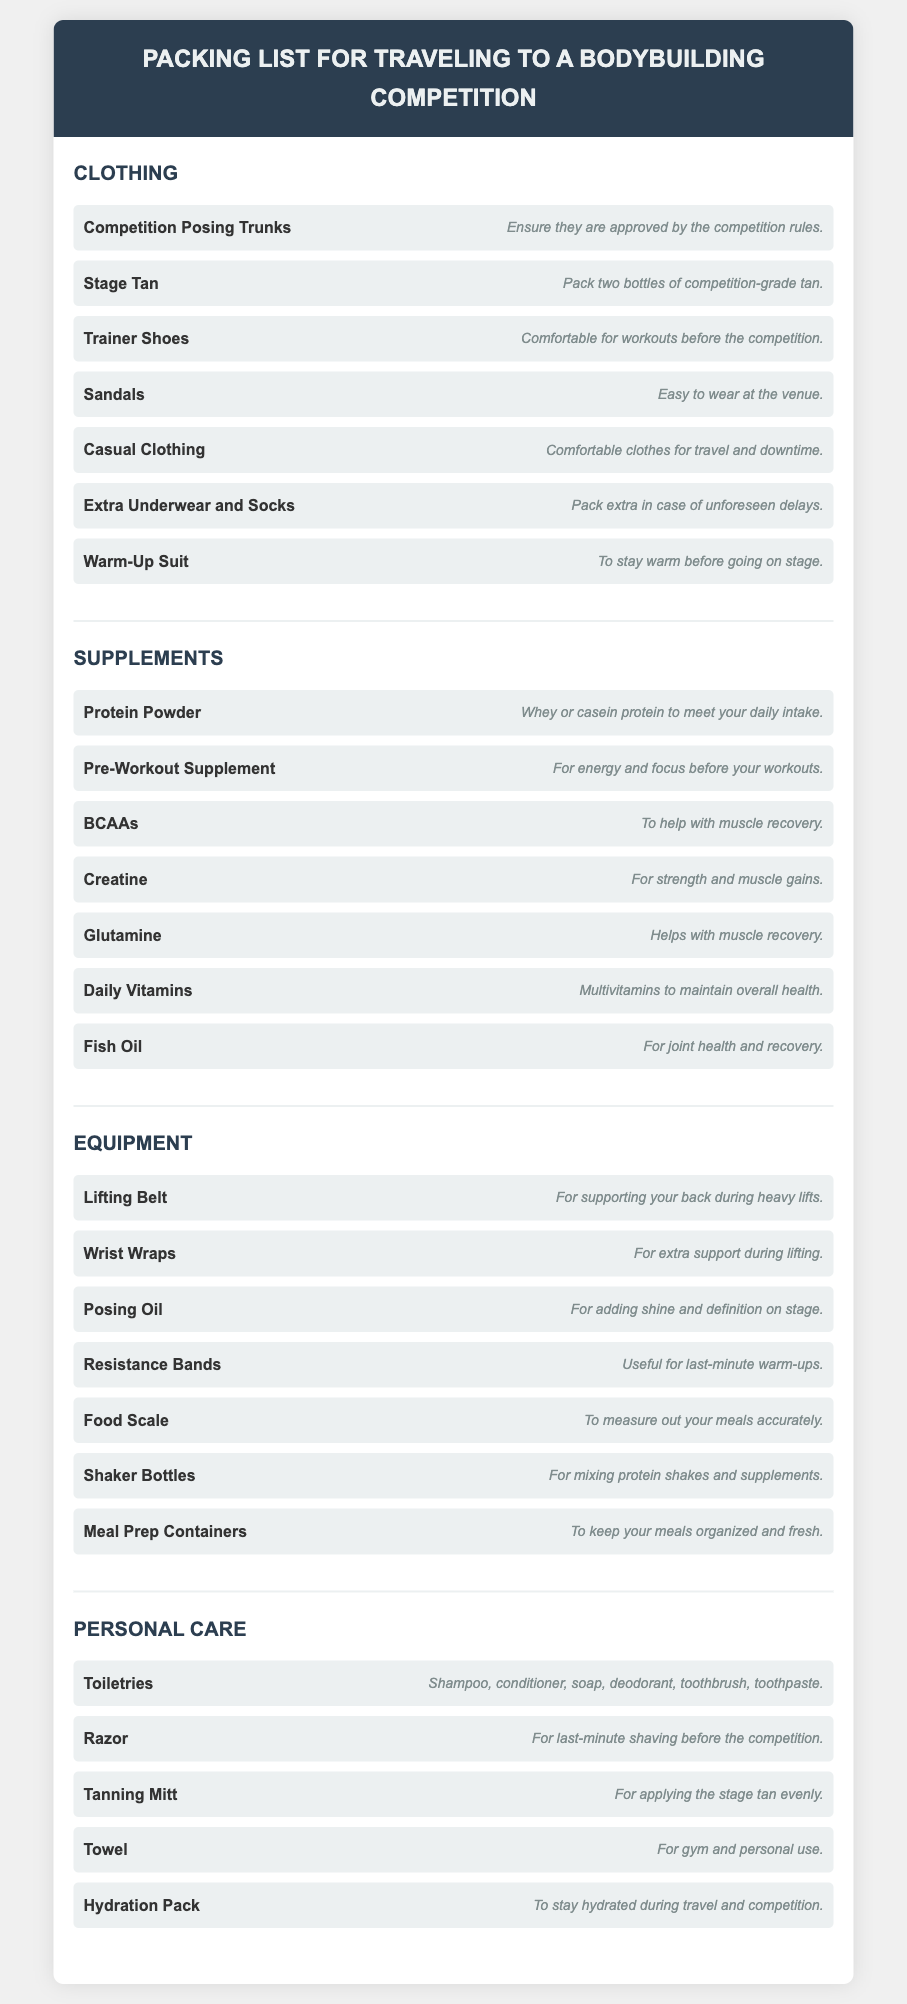what type of shoes should be packed? The document states that "Trainer Shoes" should be packed for comfort during workouts before the competition.
Answer: Trainer Shoes how many bottles of stage tan are recommended? The list suggests to "Pack two bottles of competition-grade tan."
Answer: two bottles what equipment is recommended for support during heavy lifts? The lifting support recommended in the document is the "Lifting Belt."
Answer: Lifting Belt which supplement is mentioned for muscle recovery? The document lists "BCAAs" to help with muscle recovery.
Answer: BCAAs what is one use for meal prep containers listed? "To keep your meals organized and fresh" is the purpose given for meal prep containers.
Answer: keep your meals organized and fresh what item is recommended for applying stage tan evenly? The document recommends using a "Tanning Mitt" for applying the stage tan evenly.
Answer: Tanning Mitt how many items are listed under the clothing section? The clothing section contains "seven" items, as detailed in the list.
Answer: seven what personal care item is needed for last-minute shaving? The document specifies a "Razor" for last-minute shaving before the competition.
Answer: Razor what type of pack should one bring to stay hydrated? The recommendation for hydration during travel and competition is a "Hydration Pack."
Answer: Hydration Pack 